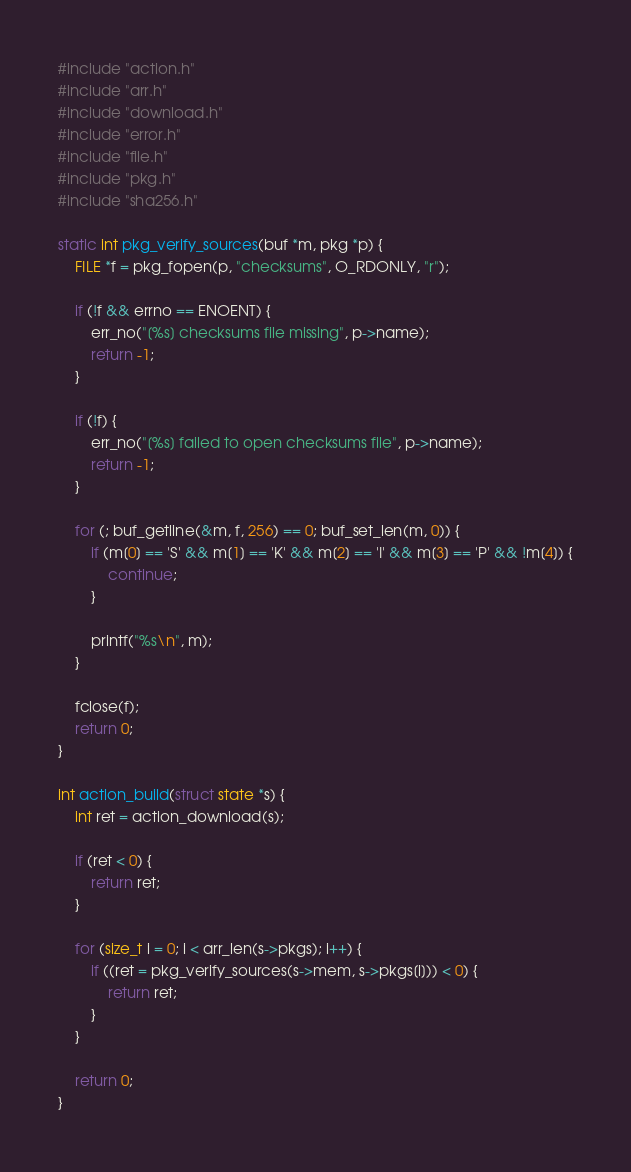Convert code to text. <code><loc_0><loc_0><loc_500><loc_500><_C_>#include "action.h"
#include "arr.h"
#include "download.h"
#include "error.h"
#include "file.h"
#include "pkg.h"
#include "sha256.h"

static int pkg_verify_sources(buf *m, pkg *p) {
    FILE *f = pkg_fopen(p, "checksums", O_RDONLY, "r");

    if (!f && errno == ENOENT) {
        err_no("[%s] checksums file missing", p->name);
        return -1;
    }

    if (!f) {
        err_no("[%s] failed to open checksums file", p->name);
        return -1;
    }

    for (; buf_getline(&m, f, 256) == 0; buf_set_len(m, 0)) {
        if (m[0] == 'S' && m[1] == 'K' && m[2] == 'I' && m[3] == 'P' && !m[4]) {
            continue;
        }

        printf("%s\n", m);
    }

    fclose(f);
    return 0;
}

int action_build(struct state *s) {
    int ret = action_download(s);

    if (ret < 0) {
        return ret;
    }

    for (size_t i = 0; i < arr_len(s->pkgs); i++) {
        if ((ret = pkg_verify_sources(s->mem, s->pkgs[i])) < 0) {
            return ret;
        }
    }

    return 0;
}

</code> 